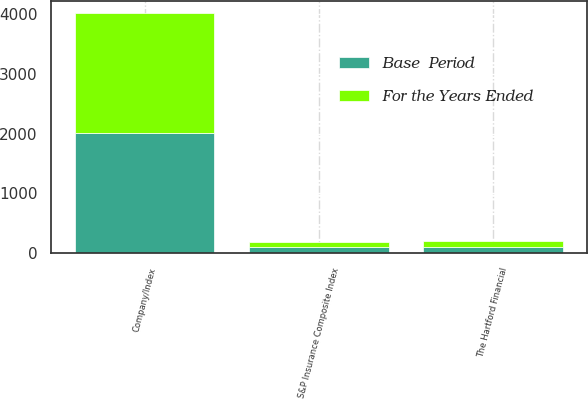<chart> <loc_0><loc_0><loc_500><loc_500><stacked_bar_chart><ecel><fcel>Company/Index<fcel>The Hartford Financial<fcel>S&P Insurance Composite Index<nl><fcel>Base  Period<fcel>2006<fcel>100<fcel>100<nl><fcel>For the Years Ended<fcel>2007<fcel>95.45<fcel>93.69<nl></chart> 